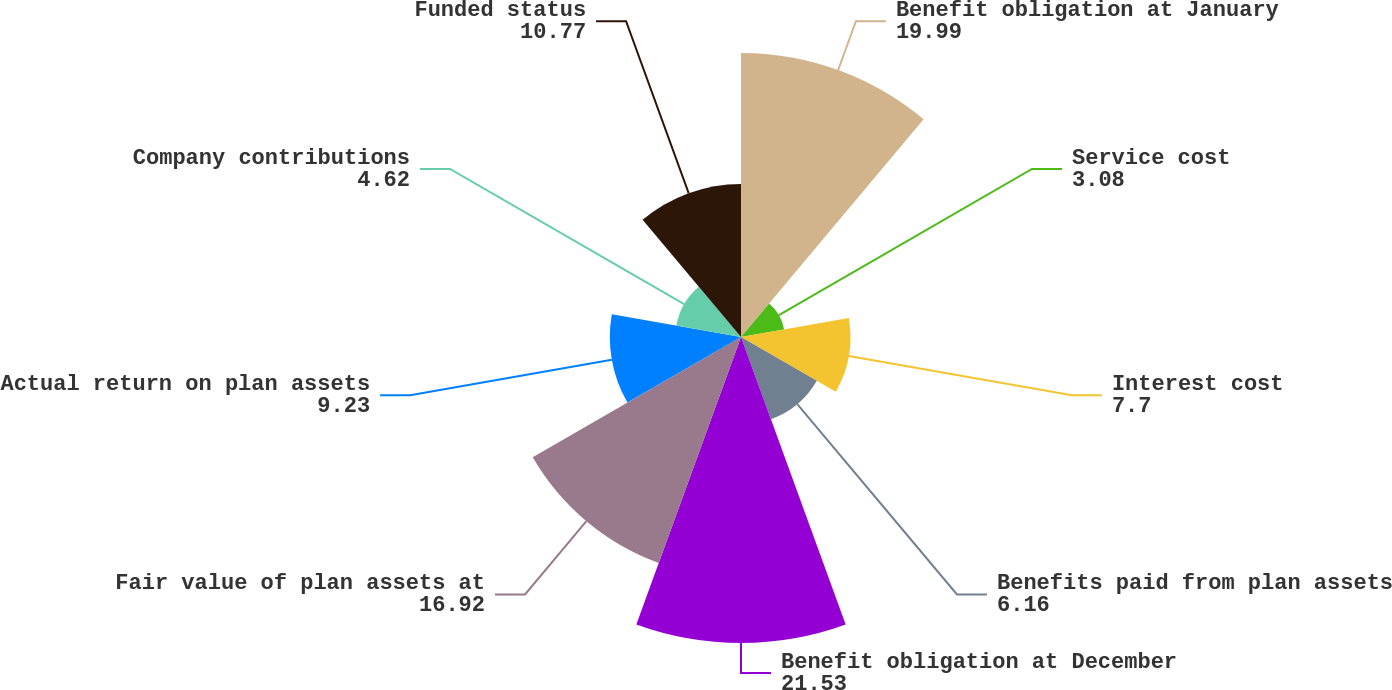Convert chart. <chart><loc_0><loc_0><loc_500><loc_500><pie_chart><fcel>Benefit obligation at January<fcel>Service cost<fcel>Interest cost<fcel>Benefits paid from plan assets<fcel>Benefit obligation at December<fcel>Fair value of plan assets at<fcel>Actual return on plan assets<fcel>Company contributions<fcel>Funded status<nl><fcel>19.99%<fcel>3.08%<fcel>7.7%<fcel>6.16%<fcel>21.53%<fcel>16.92%<fcel>9.23%<fcel>4.62%<fcel>10.77%<nl></chart> 